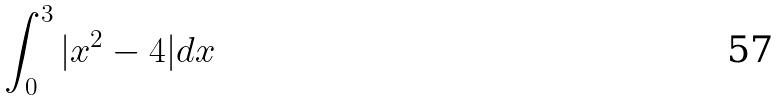<formula> <loc_0><loc_0><loc_500><loc_500>\int _ { 0 } ^ { 3 } | x ^ { 2 } - 4 | d x</formula> 